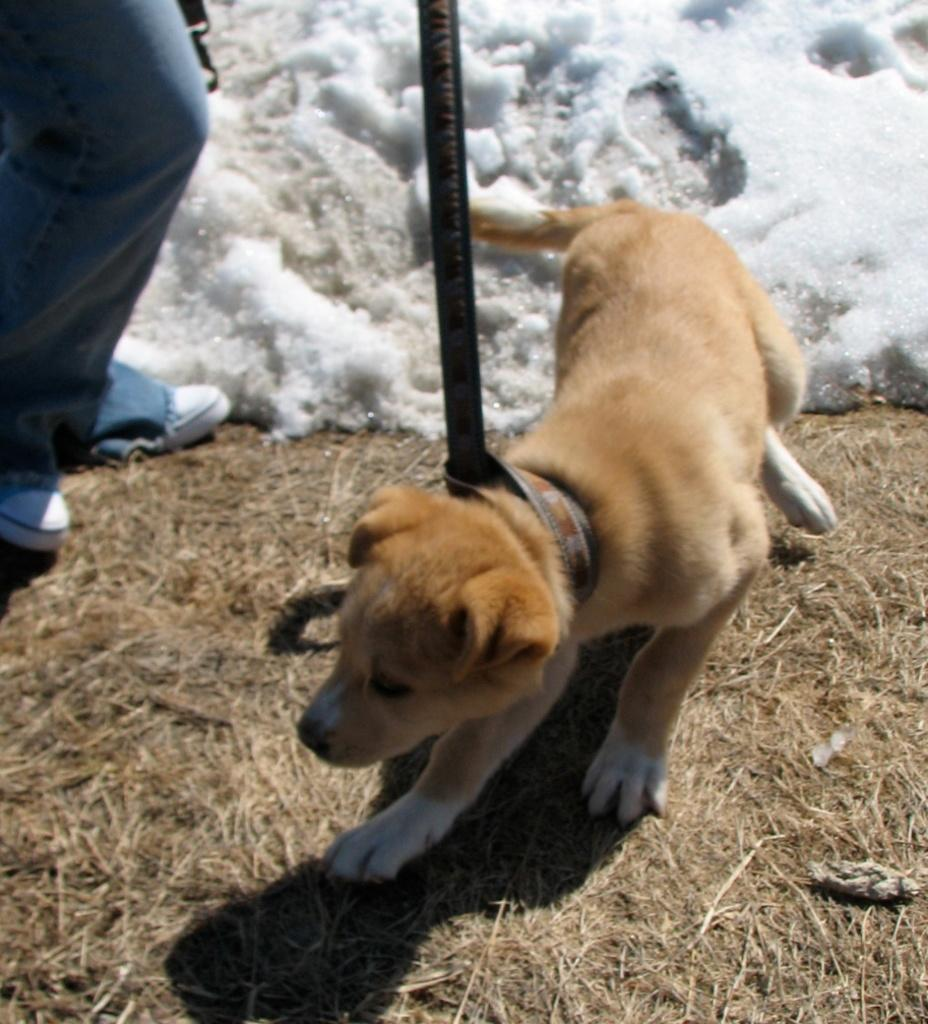What is the main subject in the foreground of the image? There is a dog in the foreground of the image. What is the dog's position in the image? The dog is on the ground. What is attached to the dog in the image? There is a belt on the dog. What can be seen on the left side of the image? There are legs of a person on the left side of the image. What type of weather is suggested by the image? There is snow visible at the top of the image, suggesting cold weather. What time of day is it in the image, and can you hear the person laughing? The time of day is not mentioned in the image, and there is no indication of laughter or any sound. Are there any jellyfish visible in the image? No, there are no jellyfish present in the image. 